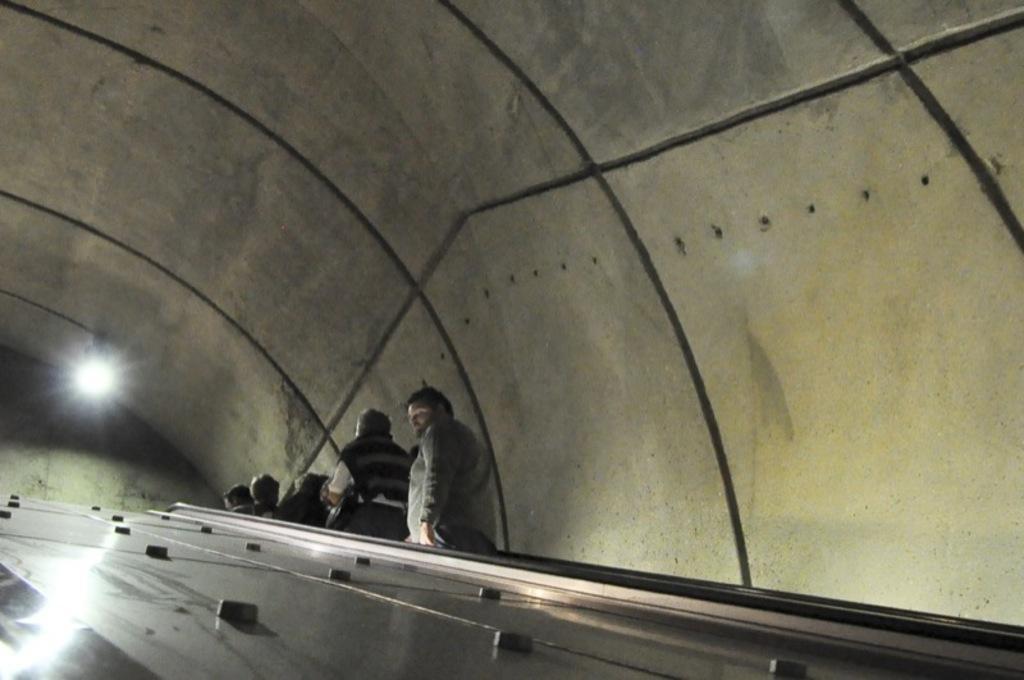Could you give a brief overview of what you see in this image? In this image I can see the tunnel which is cream and black in color and I can see few persons standing, a light and the metal surface. 